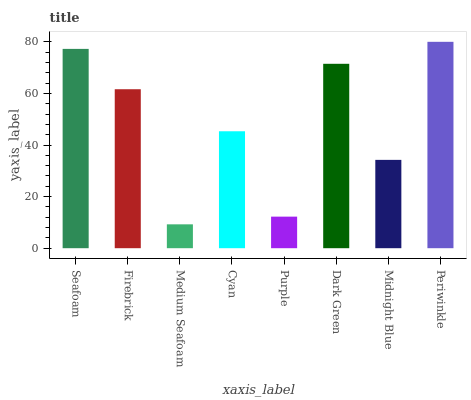Is Firebrick the minimum?
Answer yes or no. No. Is Firebrick the maximum?
Answer yes or no. No. Is Seafoam greater than Firebrick?
Answer yes or no. Yes. Is Firebrick less than Seafoam?
Answer yes or no. Yes. Is Firebrick greater than Seafoam?
Answer yes or no. No. Is Seafoam less than Firebrick?
Answer yes or no. No. Is Firebrick the high median?
Answer yes or no. Yes. Is Cyan the low median?
Answer yes or no. Yes. Is Midnight Blue the high median?
Answer yes or no. No. Is Periwinkle the low median?
Answer yes or no. No. 